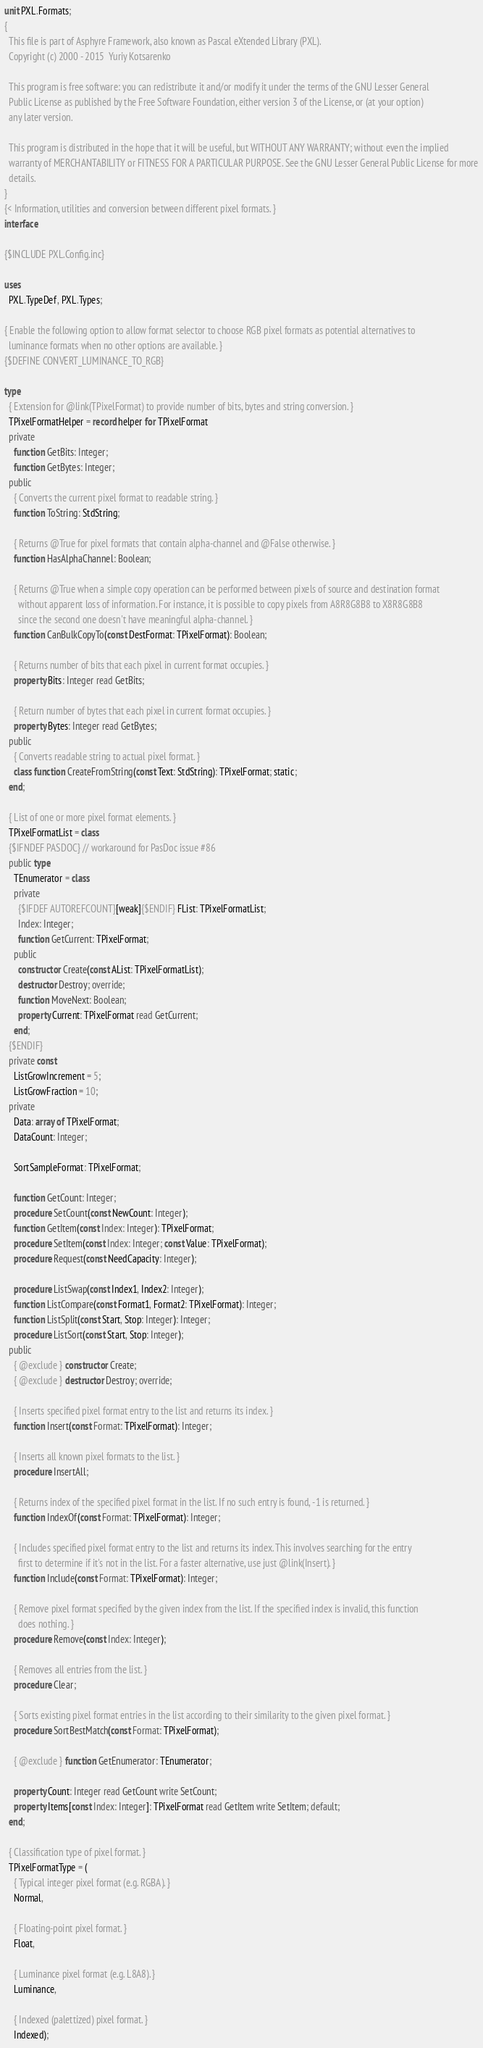<code> <loc_0><loc_0><loc_500><loc_500><_Pascal_>unit PXL.Formats;
{
  This file is part of Asphyre Framework, also known as Pascal eXtended Library (PXL).
  Copyright (c) 2000 - 2015  Yuriy Kotsarenko

  This program is free software: you can redistribute it and/or modify it under the terms of the GNU Lesser General
  Public License as published by the Free Software Foundation, either version 3 of the License, or (at your option)
  any later version.

  This program is distributed in the hope that it will be useful, but WITHOUT ANY WARRANTY; without even the implied
  warranty of MERCHANTABILITY or FITNESS FOR A PARTICULAR PURPOSE. See the GNU Lesser General Public License for more
  details.
}
{< Information, utilities and conversion between different pixel formats. }
interface

{$INCLUDE PXL.Config.inc}

uses
  PXL.TypeDef, PXL.Types;

{ Enable the following option to allow format selector to choose RGB pixel formats as potential alternatives to
  luminance formats when no other options are available. }
{$DEFINE CONVERT_LUMINANCE_TO_RGB}

type
  { Extension for @link(TPixelFormat) to provide number of bits, bytes and string conversion. }
  TPixelFormatHelper = record helper for TPixelFormat
  private
    function GetBits: Integer;
    function GetBytes: Integer;
  public
    { Converts the current pixel format to readable string. }
    function ToString: StdString;

    { Returns @True for pixel formats that contain alpha-channel and @False otherwise. }
    function HasAlphaChannel: Boolean;

    { Returns @True when a simple copy operation can be performed between pixels of source and destination format
      without apparent loss of information. For instance, it is possible to copy pixels from A8R8G8B8 to X8R8G8B8
      since the second one doesn't have meaningful alpha-channel. }
    function CanBulkCopyTo(const DestFormat: TPixelFormat): Boolean;

    { Returns number of bits that each pixel in current format occupies. }
    property Bits: Integer read GetBits;

    { Return number of bytes that each pixel in current format occupies. }
    property Bytes: Integer read GetBytes;
  public
    { Converts readable string to actual pixel format. }
    class function CreateFromString(const Text: StdString): TPixelFormat; static;
  end;

  { List of one or more pixel format elements. }
  TPixelFormatList = class
  {$IFNDEF PASDOC} // workaround for PasDoc issue #86
  public type
    TEnumerator = class
    private
      {$IFDEF AUTOREFCOUNT}[weak]{$ENDIF} FList: TPixelFormatList;
      Index: Integer;
      function GetCurrent: TPixelFormat;
    public
      constructor Create(const AList: TPixelFormatList);
      destructor Destroy; override;
      function MoveNext: Boolean;
      property Current: TPixelFormat read GetCurrent;
    end;
  {$ENDIF}
  private const
    ListGrowIncrement = 5;
    ListGrowFraction = 10;
  private
    Data: array of TPixelFormat;
    DataCount: Integer;

    SortSampleFormat: TPixelFormat;

    function GetCount: Integer;
    procedure SetCount(const NewCount: Integer);
    function GetItem(const Index: Integer): TPixelFormat;
    procedure SetItem(const Index: Integer; const Value: TPixelFormat);
    procedure Request(const NeedCapacity: Integer);

    procedure ListSwap(const Index1, Index2: Integer);
    function ListCompare(const Format1, Format2: TPixelFormat): Integer;
    function ListSplit(const Start, Stop: Integer): Integer;
    procedure ListSort(const Start, Stop: Integer);
  public
    { @exclude } constructor Create;
    { @exclude } destructor Destroy; override;

    { Inserts specified pixel format entry to the list and returns its index. }
    function Insert(const Format: TPixelFormat): Integer;

    { Inserts all known pixel formats to the list. }
    procedure InsertAll;

    { Returns index of the specified pixel format in the list. If no such entry is found, -1 is returned. }
    function IndexOf(const Format: TPixelFormat): Integer;

    { Includes specified pixel format entry to the list and returns its index. This involves searching for the entry
      first to determine if it's not in the list. For a faster alternative, use just @link(Insert). }
    function Include(const Format: TPixelFormat): Integer;

    { Remove pixel format specified by the given index from the list. If the specified index is invalid, this function
      does nothing. }
    procedure Remove(const Index: Integer);

    { Removes all entries from the list. }
    procedure Clear;

    { Sorts existing pixel format entries in the list according to their similarity to the given pixel format. }
    procedure SortBestMatch(const Format: TPixelFormat);

    { @exclude } function GetEnumerator: TEnumerator;

    property Count: Integer read GetCount write SetCount;
    property Items[const Index: Integer]: TPixelFormat read GetItem write SetItem; default;
  end;

  { Classification type of pixel format. }
  TPixelFormatType = (
    { Typical integer pixel format (e.g. RGBA). }
    Normal,

    { Floating-point pixel format. }
    Float,

    { Luminance pixel format (e.g. L8A8). }
    Luminance,

    { Indexed (palettized) pixel format. }
    Indexed);
</code> 